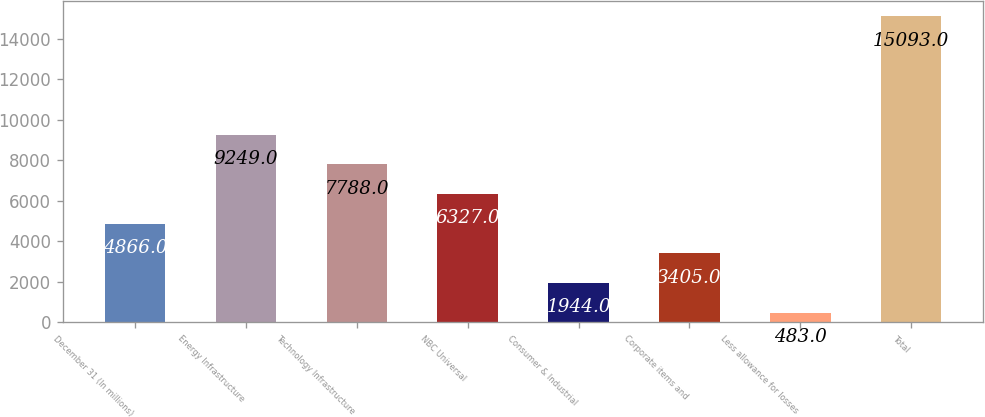Convert chart to OTSL. <chart><loc_0><loc_0><loc_500><loc_500><bar_chart><fcel>December 31 (In millions)<fcel>Energy Infrastructure<fcel>Technology Infrastructure<fcel>NBC Universal<fcel>Consumer & Industrial<fcel>Corporate items and<fcel>Less allowance for losses<fcel>Total<nl><fcel>4866<fcel>9249<fcel>7788<fcel>6327<fcel>1944<fcel>3405<fcel>483<fcel>15093<nl></chart> 